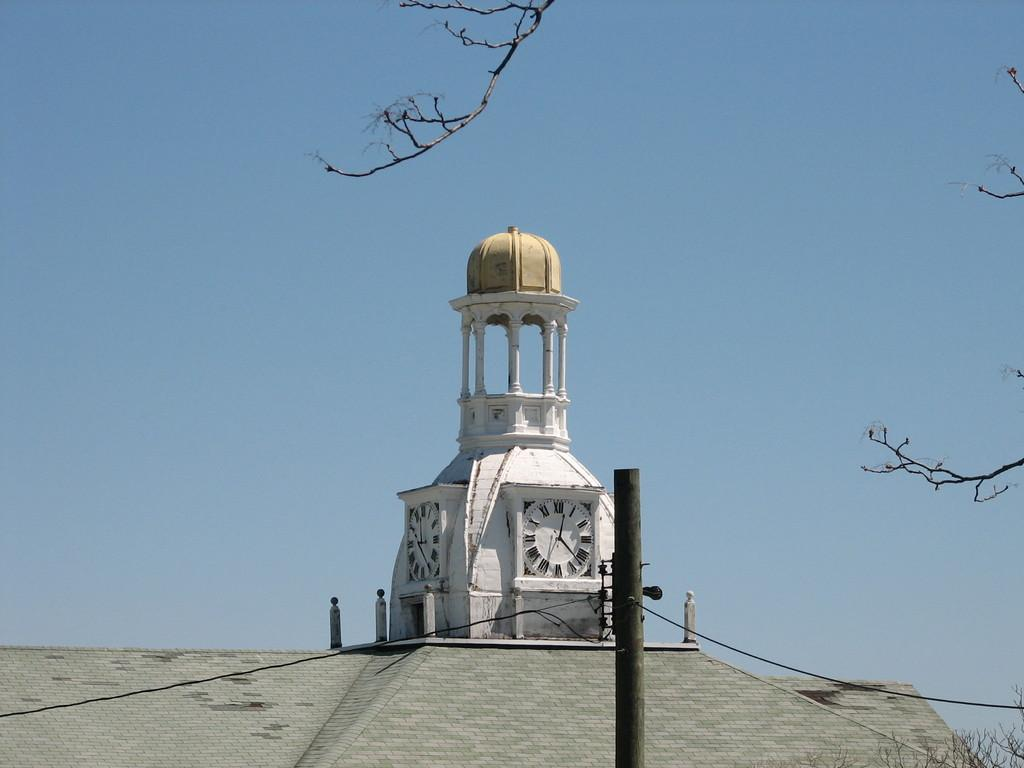What is located on the building in the image? There is a clock on a building in the image. What can be seen at the top of the image? The sky is visible at the top of the image. How does the clock help the person in the image breathe better? The image does not show a person or any indication of breathing issues, so it is not possible to determine how the clock might help with breathing. 